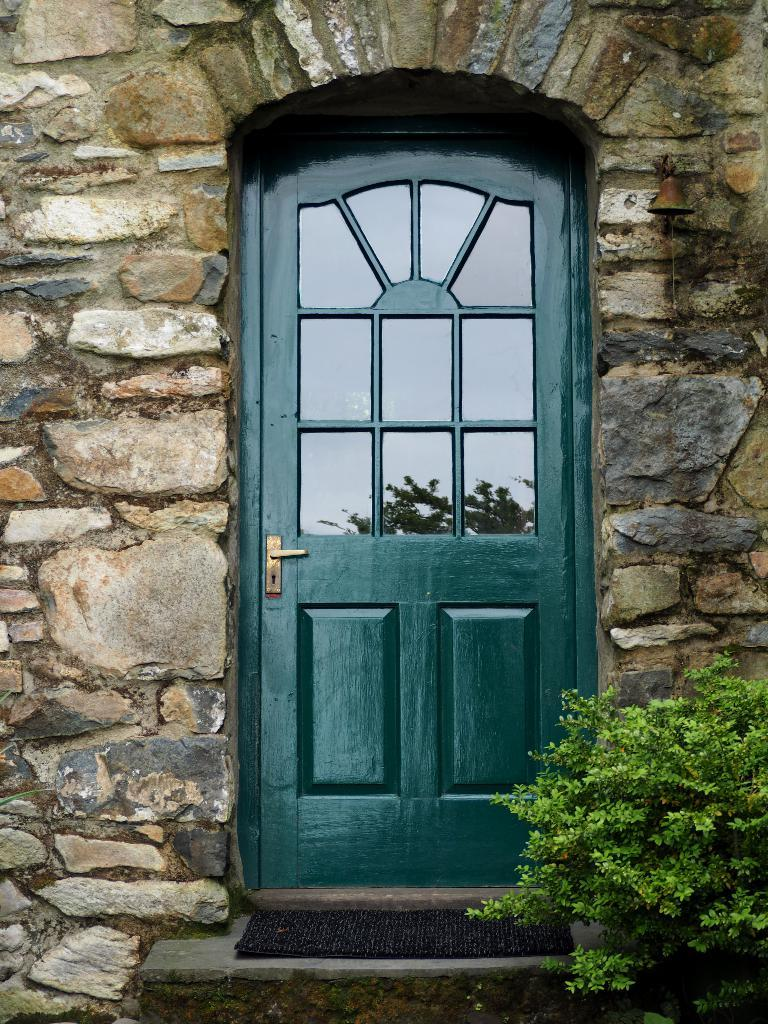What is located in the center of the image? There is a wall, a door, a staircase, and a plant in the center of the image. Can you describe the door in the image? The door is in the center of the image, and it is likely the entrance to a building or room. What is the purpose of the staircase in the image? The staircase in the image provides access to different levels or floors of a building or structure. What type of plant is present in the image? The plant in the center of the image is not specified, but it could be a potted plant or a decorative plant. Can you tell me how many frogs are sitting on the edge of the staircase in the image? There are no frogs present in the image, and therefore no such activity can be observed. What type of stamp is visible on the door in the image? There is no stamp visible on the door in the image. 